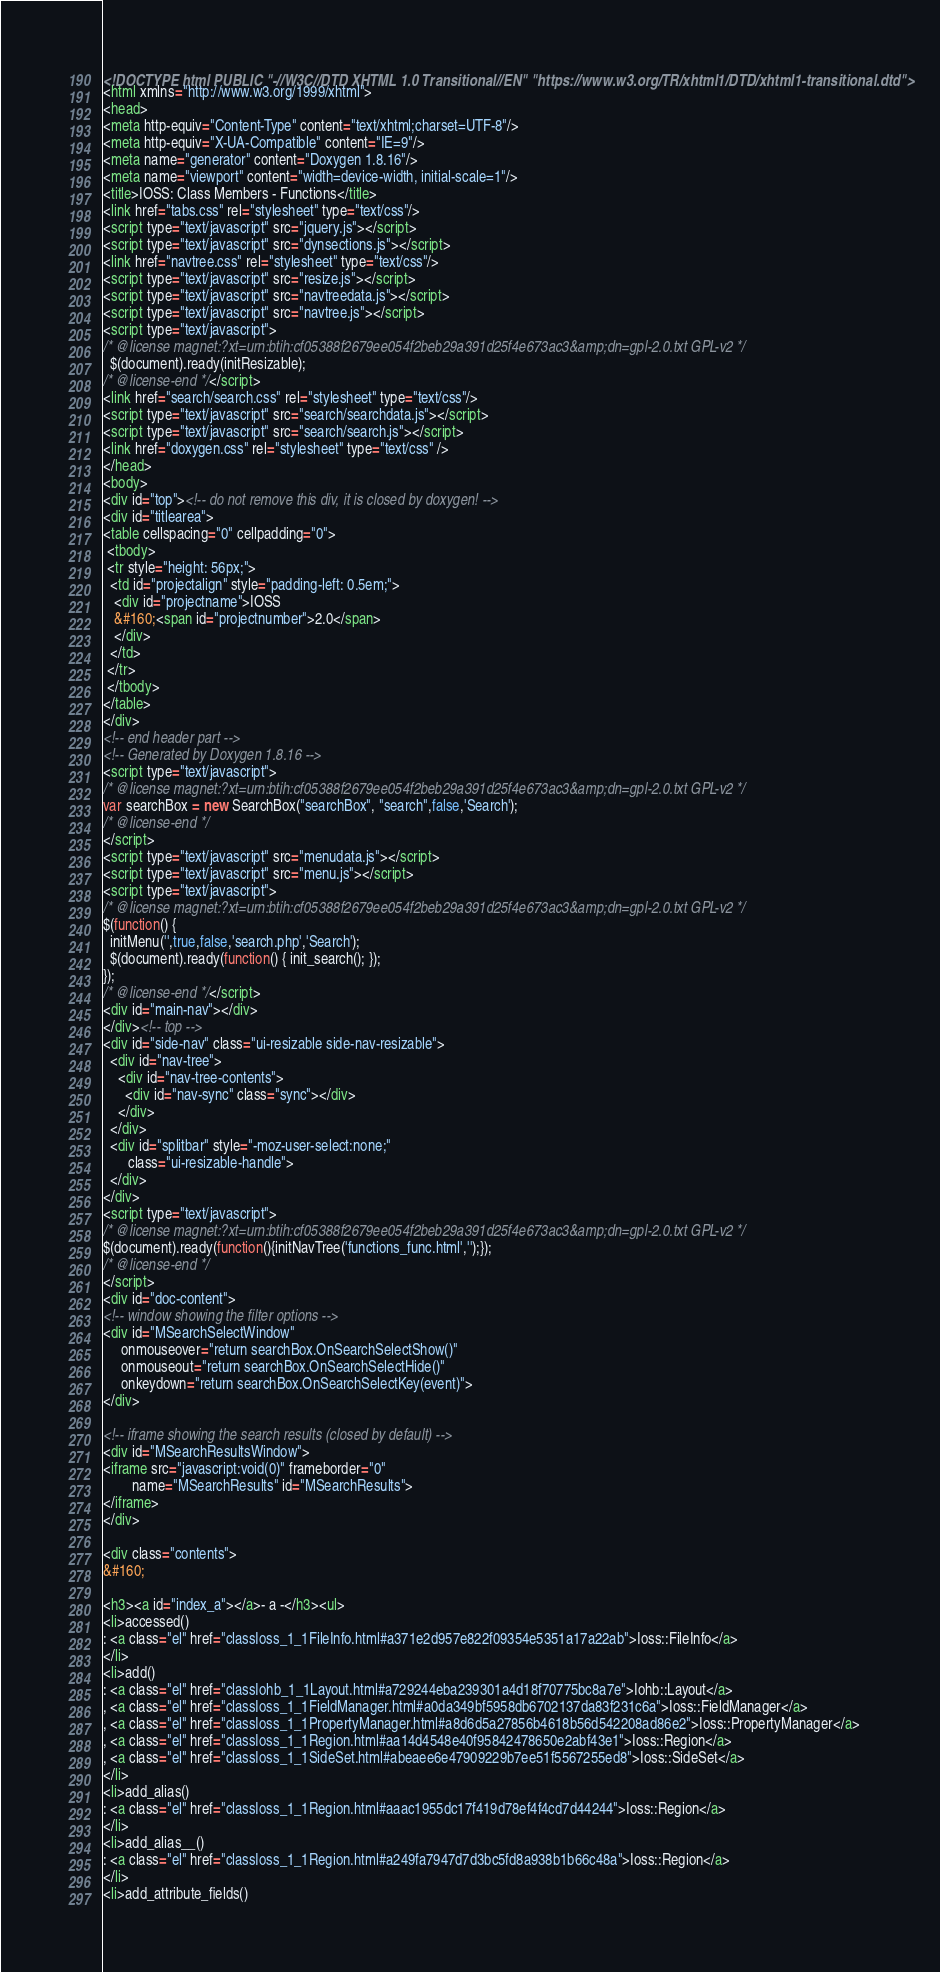Convert code to text. <code><loc_0><loc_0><loc_500><loc_500><_HTML_><!DOCTYPE html PUBLIC "-//W3C//DTD XHTML 1.0 Transitional//EN" "https://www.w3.org/TR/xhtml1/DTD/xhtml1-transitional.dtd">
<html xmlns="http://www.w3.org/1999/xhtml">
<head>
<meta http-equiv="Content-Type" content="text/xhtml;charset=UTF-8"/>
<meta http-equiv="X-UA-Compatible" content="IE=9"/>
<meta name="generator" content="Doxygen 1.8.16"/>
<meta name="viewport" content="width=device-width, initial-scale=1"/>
<title>IOSS: Class Members - Functions</title>
<link href="tabs.css" rel="stylesheet" type="text/css"/>
<script type="text/javascript" src="jquery.js"></script>
<script type="text/javascript" src="dynsections.js"></script>
<link href="navtree.css" rel="stylesheet" type="text/css"/>
<script type="text/javascript" src="resize.js"></script>
<script type="text/javascript" src="navtreedata.js"></script>
<script type="text/javascript" src="navtree.js"></script>
<script type="text/javascript">
/* @license magnet:?xt=urn:btih:cf05388f2679ee054f2beb29a391d25f4e673ac3&amp;dn=gpl-2.0.txt GPL-v2 */
  $(document).ready(initResizable);
/* @license-end */</script>
<link href="search/search.css" rel="stylesheet" type="text/css"/>
<script type="text/javascript" src="search/searchdata.js"></script>
<script type="text/javascript" src="search/search.js"></script>
<link href="doxygen.css" rel="stylesheet" type="text/css" />
</head>
<body>
<div id="top"><!-- do not remove this div, it is closed by doxygen! -->
<div id="titlearea">
<table cellspacing="0" cellpadding="0">
 <tbody>
 <tr style="height: 56px;">
  <td id="projectalign" style="padding-left: 0.5em;">
   <div id="projectname">IOSS
   &#160;<span id="projectnumber">2.0</span>
   </div>
  </td>
 </tr>
 </tbody>
</table>
</div>
<!-- end header part -->
<!-- Generated by Doxygen 1.8.16 -->
<script type="text/javascript">
/* @license magnet:?xt=urn:btih:cf05388f2679ee054f2beb29a391d25f4e673ac3&amp;dn=gpl-2.0.txt GPL-v2 */
var searchBox = new SearchBox("searchBox", "search",false,'Search');
/* @license-end */
</script>
<script type="text/javascript" src="menudata.js"></script>
<script type="text/javascript" src="menu.js"></script>
<script type="text/javascript">
/* @license magnet:?xt=urn:btih:cf05388f2679ee054f2beb29a391d25f4e673ac3&amp;dn=gpl-2.0.txt GPL-v2 */
$(function() {
  initMenu('',true,false,'search.php','Search');
  $(document).ready(function() { init_search(); });
});
/* @license-end */</script>
<div id="main-nav"></div>
</div><!-- top -->
<div id="side-nav" class="ui-resizable side-nav-resizable">
  <div id="nav-tree">
    <div id="nav-tree-contents">
      <div id="nav-sync" class="sync"></div>
    </div>
  </div>
  <div id="splitbar" style="-moz-user-select:none;" 
       class="ui-resizable-handle">
  </div>
</div>
<script type="text/javascript">
/* @license magnet:?xt=urn:btih:cf05388f2679ee054f2beb29a391d25f4e673ac3&amp;dn=gpl-2.0.txt GPL-v2 */
$(document).ready(function(){initNavTree('functions_func.html','');});
/* @license-end */
</script>
<div id="doc-content">
<!-- window showing the filter options -->
<div id="MSearchSelectWindow"
     onmouseover="return searchBox.OnSearchSelectShow()"
     onmouseout="return searchBox.OnSearchSelectHide()"
     onkeydown="return searchBox.OnSearchSelectKey(event)">
</div>

<!-- iframe showing the search results (closed by default) -->
<div id="MSearchResultsWindow">
<iframe src="javascript:void(0)" frameborder="0" 
        name="MSearchResults" id="MSearchResults">
</iframe>
</div>

<div class="contents">
&#160;

<h3><a id="index_a"></a>- a -</h3><ul>
<li>accessed()
: <a class="el" href="classIoss_1_1FileInfo.html#a371e2d957e822f09354e5351a17a22ab">Ioss::FileInfo</a>
</li>
<li>add()
: <a class="el" href="classIohb_1_1Layout.html#a729244eba239301a4d18f70775bc8a7e">Iohb::Layout</a>
, <a class="el" href="classIoss_1_1FieldManager.html#a0da349bf5958db6702137da83f231c6a">Ioss::FieldManager</a>
, <a class="el" href="classIoss_1_1PropertyManager.html#a8d6d5a27856b4618b56d542208ad86e2">Ioss::PropertyManager</a>
, <a class="el" href="classIoss_1_1Region.html#aa14d4548e40f95842478650e2abf43e1">Ioss::Region</a>
, <a class="el" href="classIoss_1_1SideSet.html#abeaee6e47909229b7ee51f5567255ed8">Ioss::SideSet</a>
</li>
<li>add_alias()
: <a class="el" href="classIoss_1_1Region.html#aaac1955dc17f419d78ef4f4cd7d44244">Ioss::Region</a>
</li>
<li>add_alias__()
: <a class="el" href="classIoss_1_1Region.html#a249fa7947d7d3bc5fd8a938b1b66c48a">Ioss::Region</a>
</li>
<li>add_attribute_fields()</code> 